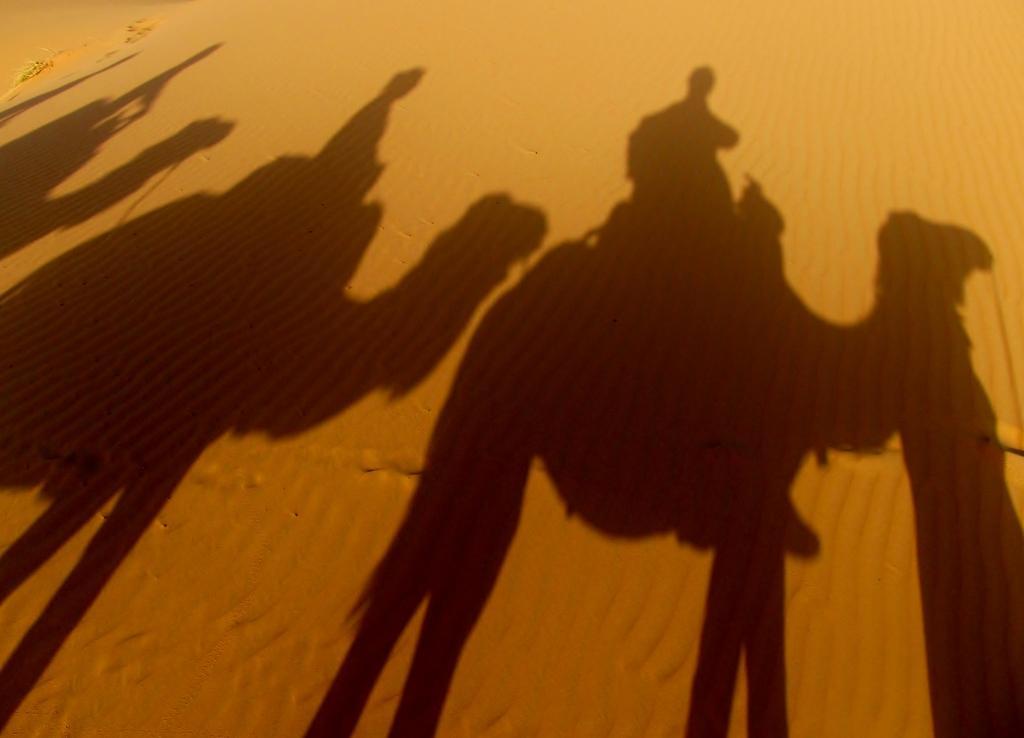Please provide a concise description of this image. In this picture we can see a desert. On the sand we can see the reflection of people and camels. 